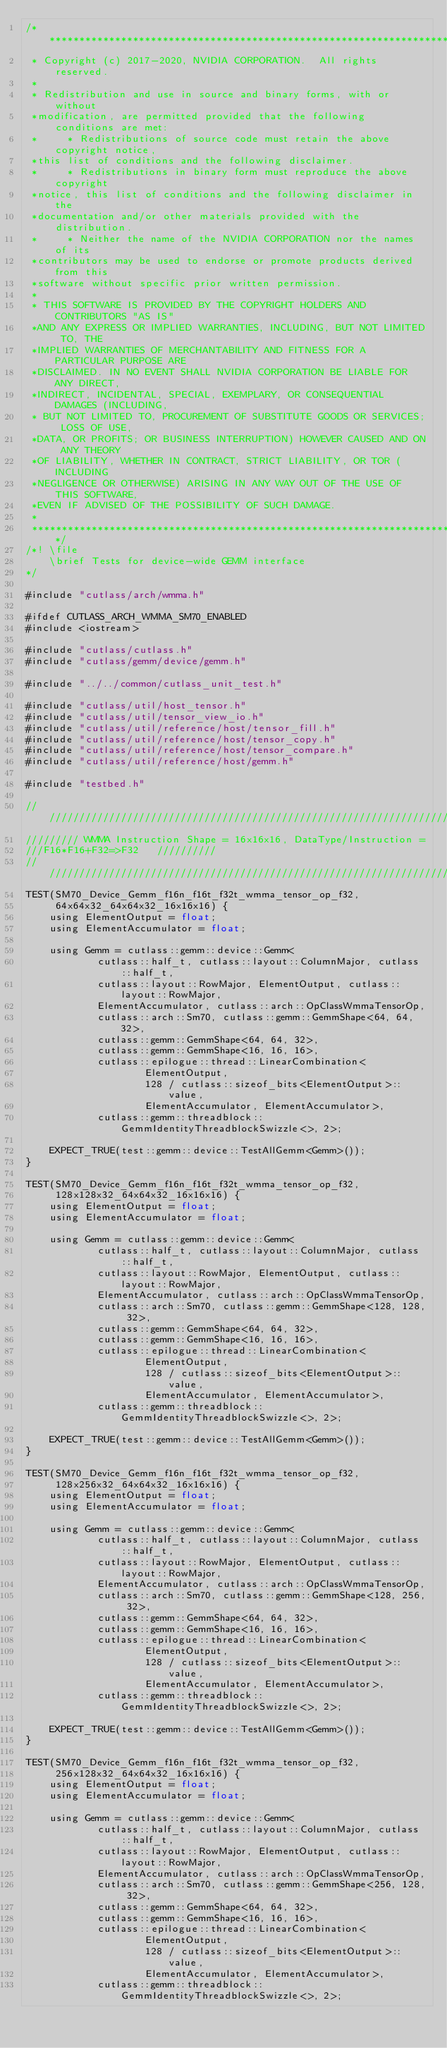Convert code to text. <code><loc_0><loc_0><loc_500><loc_500><_Cuda_>/***************************************************************************************************
 * Copyright (c) 2017-2020, NVIDIA CORPORATION.  All rights reserved.
 *
 * Redistribution and use in source and binary forms, with or without
 *modification, are permitted provided that the following conditions are met:
 *     * Redistributions of source code must retain the above copyright notice,
 *this list of conditions and the following disclaimer.
 *     * Redistributions in binary form must reproduce the above copyright
 *notice, this list of conditions and the following disclaimer in the
 *documentation and/or other materials provided with the distribution.
 *     * Neither the name of the NVIDIA CORPORATION nor the names of its
 *contributors may be used to endorse or promote products derived from this
 *software without specific prior written permission.
 *
 * THIS SOFTWARE IS PROVIDED BY THE COPYRIGHT HOLDERS AND CONTRIBUTORS "AS IS"
 *AND ANY EXPRESS OR IMPLIED WARRANTIES, INCLUDING, BUT NOT LIMITED TO, THE
 *IMPLIED WARRANTIES OF MERCHANTABILITY AND FITNESS FOR A PARTICULAR PURPOSE ARE
 *DISCLAIMED. IN NO EVENT SHALL NVIDIA CORPORATION BE LIABLE FOR ANY DIRECT,
 *INDIRECT, INCIDENTAL, SPECIAL, EXEMPLARY, OR CONSEQUENTIAL DAMAGES (INCLUDING,
 * BUT NOT LIMITED TO, PROCUREMENT OF SUBSTITUTE GOODS OR SERVICES; LOSS OF USE,
 *DATA, OR PROFITS; OR BUSINESS INTERRUPTION) HOWEVER CAUSED AND ON ANY THEORY
 *OF LIABILITY, WHETHER IN CONTRACT, STRICT LIABILITY, OR TOR (INCLUDING
 *NEGLIGENCE OR OTHERWISE) ARISING IN ANY WAY OUT OF THE USE OF THIS SOFTWARE,
 *EVEN IF ADVISED OF THE POSSIBILITY OF SUCH DAMAGE.
 *
 **************************************************************************************************/
/*! \file
    \brief Tests for device-wide GEMM interface
*/

#include "cutlass/arch/wmma.h"

#ifdef CUTLASS_ARCH_WMMA_SM70_ENABLED
#include <iostream>

#include "cutlass/cutlass.h"
#include "cutlass/gemm/device/gemm.h"

#include "../../common/cutlass_unit_test.h"

#include "cutlass/util/host_tensor.h"
#include "cutlass/util/tensor_view_io.h"
#include "cutlass/util/reference/host/tensor_fill.h"
#include "cutlass/util/reference/host/tensor_copy.h"
#include "cutlass/util/reference/host/tensor_compare.h"
#include "cutlass/util/reference/host/gemm.h"

#include "testbed.h"

/////////////////////////////////////////////////////////////////////////////////////////////////
///////// WMMA Instruction Shape = 16x16x16, DataType/Instruction =
///F16*F16+F32=>F32   //////////
/////////////////////////////////////////////////////////////////////////////////////////////////
TEST(SM70_Device_Gemm_f16n_f16t_f32t_wmma_tensor_op_f32,
     64x64x32_64x64x32_16x16x16) {
    using ElementOutput = float;
    using ElementAccumulator = float;

    using Gemm = cutlass::gemm::device::Gemm<
            cutlass::half_t, cutlass::layout::ColumnMajor, cutlass::half_t,
            cutlass::layout::RowMajor, ElementOutput, cutlass::layout::RowMajor,
            ElementAccumulator, cutlass::arch::OpClassWmmaTensorOp,
            cutlass::arch::Sm70, cutlass::gemm::GemmShape<64, 64, 32>,
            cutlass::gemm::GemmShape<64, 64, 32>,
            cutlass::gemm::GemmShape<16, 16, 16>,
            cutlass::epilogue::thread::LinearCombination<
                    ElementOutput,
                    128 / cutlass::sizeof_bits<ElementOutput>::value,
                    ElementAccumulator, ElementAccumulator>,
            cutlass::gemm::threadblock::GemmIdentityThreadblockSwizzle<>, 2>;

    EXPECT_TRUE(test::gemm::device::TestAllGemm<Gemm>());
}

TEST(SM70_Device_Gemm_f16n_f16t_f32t_wmma_tensor_op_f32,
     128x128x32_64x64x32_16x16x16) {
    using ElementOutput = float;
    using ElementAccumulator = float;

    using Gemm = cutlass::gemm::device::Gemm<
            cutlass::half_t, cutlass::layout::ColumnMajor, cutlass::half_t,
            cutlass::layout::RowMajor, ElementOutput, cutlass::layout::RowMajor,
            ElementAccumulator, cutlass::arch::OpClassWmmaTensorOp,
            cutlass::arch::Sm70, cutlass::gemm::GemmShape<128, 128, 32>,
            cutlass::gemm::GemmShape<64, 64, 32>,
            cutlass::gemm::GemmShape<16, 16, 16>,
            cutlass::epilogue::thread::LinearCombination<
                    ElementOutput,
                    128 / cutlass::sizeof_bits<ElementOutput>::value,
                    ElementAccumulator, ElementAccumulator>,
            cutlass::gemm::threadblock::GemmIdentityThreadblockSwizzle<>, 2>;

    EXPECT_TRUE(test::gemm::device::TestAllGemm<Gemm>());
}

TEST(SM70_Device_Gemm_f16n_f16t_f32t_wmma_tensor_op_f32,
     128x256x32_64x64x32_16x16x16) {
    using ElementOutput = float;
    using ElementAccumulator = float;

    using Gemm = cutlass::gemm::device::Gemm<
            cutlass::half_t, cutlass::layout::ColumnMajor, cutlass::half_t,
            cutlass::layout::RowMajor, ElementOutput, cutlass::layout::RowMajor,
            ElementAccumulator, cutlass::arch::OpClassWmmaTensorOp,
            cutlass::arch::Sm70, cutlass::gemm::GemmShape<128, 256, 32>,
            cutlass::gemm::GemmShape<64, 64, 32>,
            cutlass::gemm::GemmShape<16, 16, 16>,
            cutlass::epilogue::thread::LinearCombination<
                    ElementOutput,
                    128 / cutlass::sizeof_bits<ElementOutput>::value,
                    ElementAccumulator, ElementAccumulator>,
            cutlass::gemm::threadblock::GemmIdentityThreadblockSwizzle<>, 2>;

    EXPECT_TRUE(test::gemm::device::TestAllGemm<Gemm>());
}

TEST(SM70_Device_Gemm_f16n_f16t_f32t_wmma_tensor_op_f32,
     256x128x32_64x64x32_16x16x16) {
    using ElementOutput = float;
    using ElementAccumulator = float;

    using Gemm = cutlass::gemm::device::Gemm<
            cutlass::half_t, cutlass::layout::ColumnMajor, cutlass::half_t,
            cutlass::layout::RowMajor, ElementOutput, cutlass::layout::RowMajor,
            ElementAccumulator, cutlass::arch::OpClassWmmaTensorOp,
            cutlass::arch::Sm70, cutlass::gemm::GemmShape<256, 128, 32>,
            cutlass::gemm::GemmShape<64, 64, 32>,
            cutlass::gemm::GemmShape<16, 16, 16>,
            cutlass::epilogue::thread::LinearCombination<
                    ElementOutput,
                    128 / cutlass::sizeof_bits<ElementOutput>::value,
                    ElementAccumulator, ElementAccumulator>,
            cutlass::gemm::threadblock::GemmIdentityThreadblockSwizzle<>, 2>;
</code> 